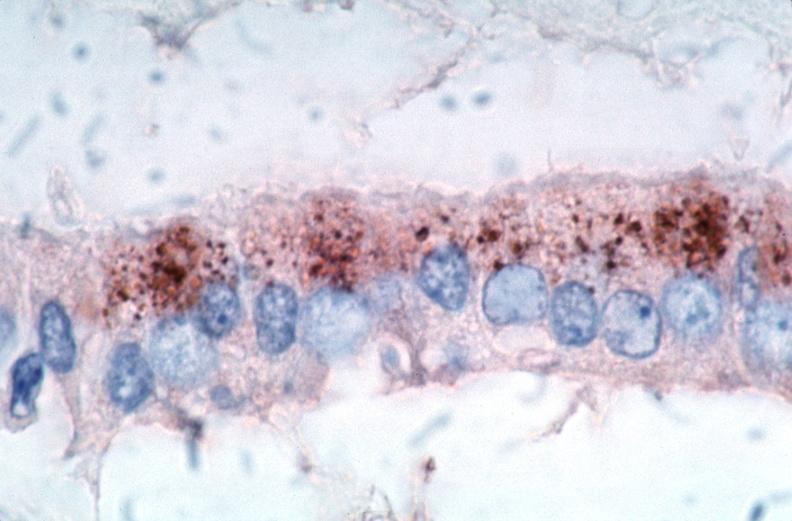s cardiovascular present?
Answer the question using a single word or phrase. Yes 